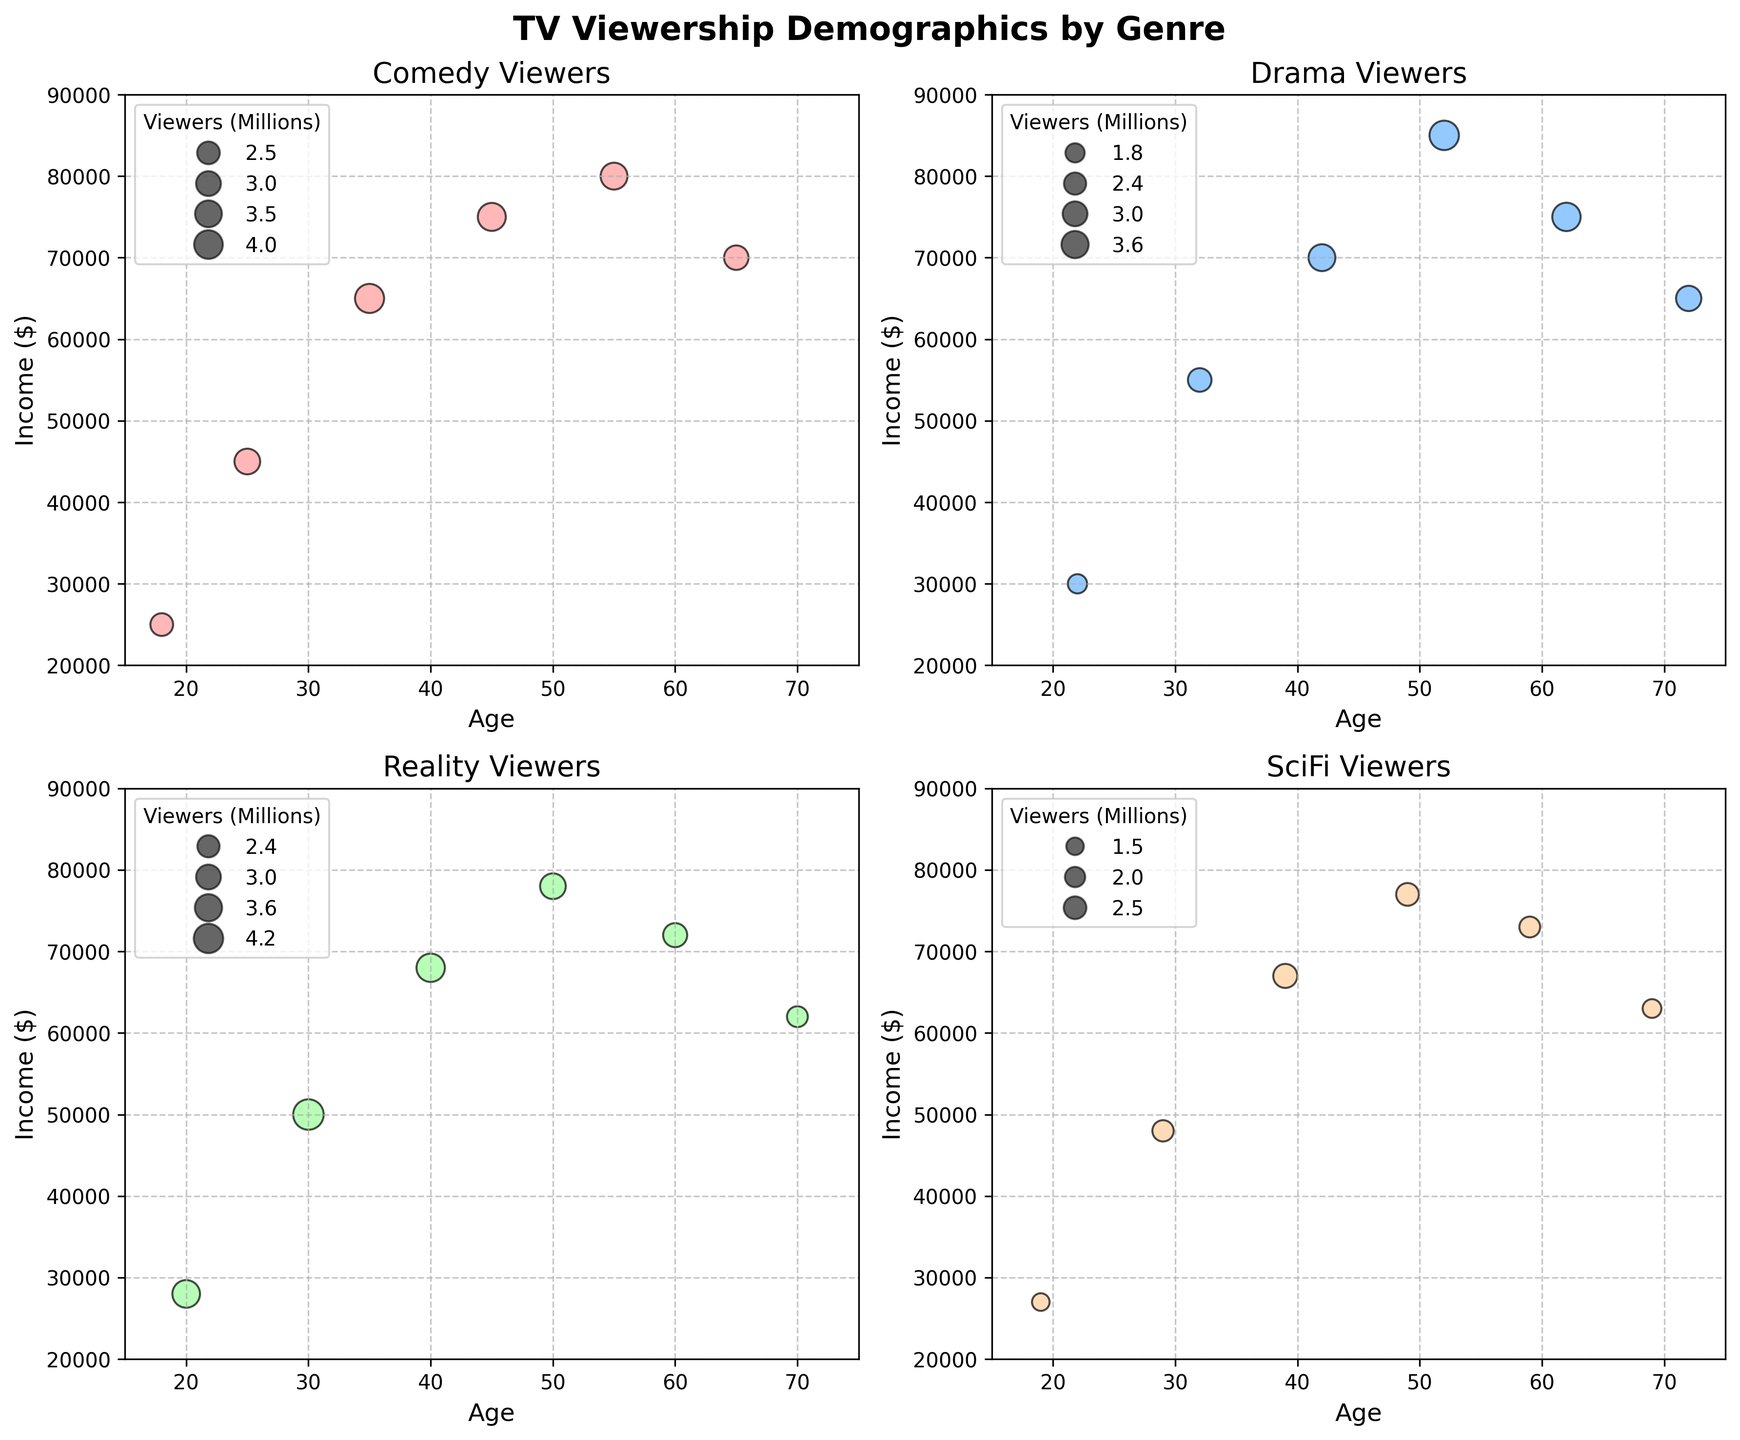What is the title of the entire figure? The title of the entire figure is seen at the top of the image. It reads "TV Viewership Demographics by Genre," indicating the overall subject of the plotted data.
Answer: TV Viewership Demographics by Genre What are the X and Y axis labels for each subplot? Each subplot represents a different genre of TV shows and includes labels for the axes. The X-axis is labeled "Age," and the Y-axis is labeled "Income ($)." This can be seen clearly on all four subplots.
Answer: Age, Income ($) Which genre has the subplot with the highest number of viewers for a single data point? By comparing the size of the bubbles (which represent the number of viewers), we can see that the Reality genre subplot has the biggest bubble, indicating the highest viewership for a single data point, specifically for Age 30 and Income $50,000.
Answer: Reality In the Comedy subplot, what is the range of incomes for which data points are presented? Observing the Comedy subplot, we can determine the range of incomes by identifying the minimum and maximum income values represented by the data points. The lowest income is $25,000, and the highest is $80,000.
Answer: $25,000 - $80,000 How does the viewership for Drama change with age? By examining the size of the bubbles in the Drama subplot, we can observe that viewership tends to increase with age up to around 52 years old and then starts to decrease for older age ranges. This is indicated by the sizes of the bubbles growing until 52 years and then shrinking.
Answer: Increases up to 52 years, then decreases Which genre has the widest age range among its viewership? To determine the genre with the widest age range, we look at the minimum and maximum age values in each subplot. The Reality genre has data points ranging from age 20 to 70, which is the widest age range among the genres.
Answer: Reality Comparing Compositional: What is the average number of viewers for SciFi shows between ages 29 and 49? To find the average number of viewers for SciFi shows between ages 29 and 49, we sum up the number of viewers in that range and then divide by the number of data points. The viewers' numbers are 2.2, 2.8, and 2.5 (ages 29, 39, and 49 respectively). The total is 2.2 + 2.8 + 2.5 = 7.5, and there are 3 data points, so the average is 7.5/3 = 2.5.
Answer: 2.5 Which age group has the smallest viewership for Reality TV? To find the smallest viewership for Reality TV, look for the smallest bubble in the Reality subplot. The smallest bubble appears at age 70 with an income of $62,000, representing 2.1 million viewers.
Answer: Age 70 Which genre shows the highest income range among its viewership? To find the genre with the highest income range, we compare the income ranges for each subplot. The Drama genre has the highest income range, spanning from $30,000 to $85,000.
Answer: Drama Is there a genre where younger viewers (18-22) have higher income levels than older viewers (55-65)? To answer this, we need to compare incomes of younger (18-22) and older (55-65) viewers within each genre. In the Comedy genre, younger viewers (ages 18 and 25) have incomes of $25,000 and $45,000 respectively, while older viewers (ages 55 and 65) have incomes of $80,000 and $70,000, showing that older viewers have higher incomes. This negates the query. Similarly, none of the other subplots (Drama, Reality, SciFi) show younger viewers having higher incomes than older viewers.
Answer: No 